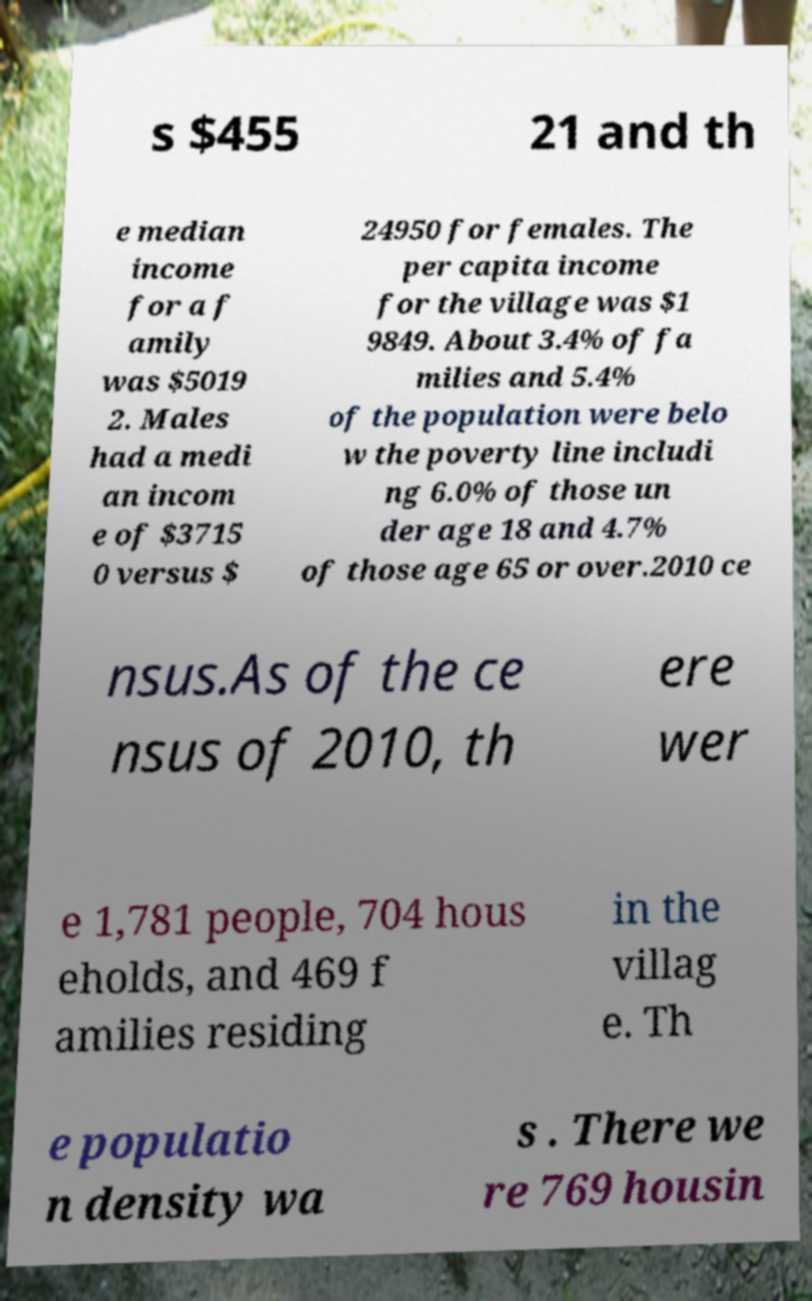Could you assist in decoding the text presented in this image and type it out clearly? s $455 21 and th e median income for a f amily was $5019 2. Males had a medi an incom e of $3715 0 versus $ 24950 for females. The per capita income for the village was $1 9849. About 3.4% of fa milies and 5.4% of the population were belo w the poverty line includi ng 6.0% of those un der age 18 and 4.7% of those age 65 or over.2010 ce nsus.As of the ce nsus of 2010, th ere wer e 1,781 people, 704 hous eholds, and 469 f amilies residing in the villag e. Th e populatio n density wa s . There we re 769 housin 